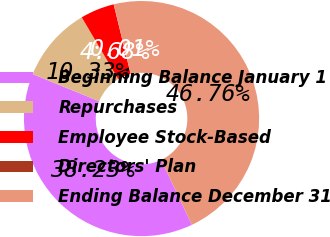Convert chart to OTSL. <chart><loc_0><loc_0><loc_500><loc_500><pie_chart><fcel>Beginning Balance January 1<fcel>Repurchases<fcel>Employee Stock-Based<fcel>Directors' Plan<fcel>Ending Balance December 31<nl><fcel>38.23%<fcel>10.33%<fcel>4.68%<fcel>0.01%<fcel>46.76%<nl></chart> 